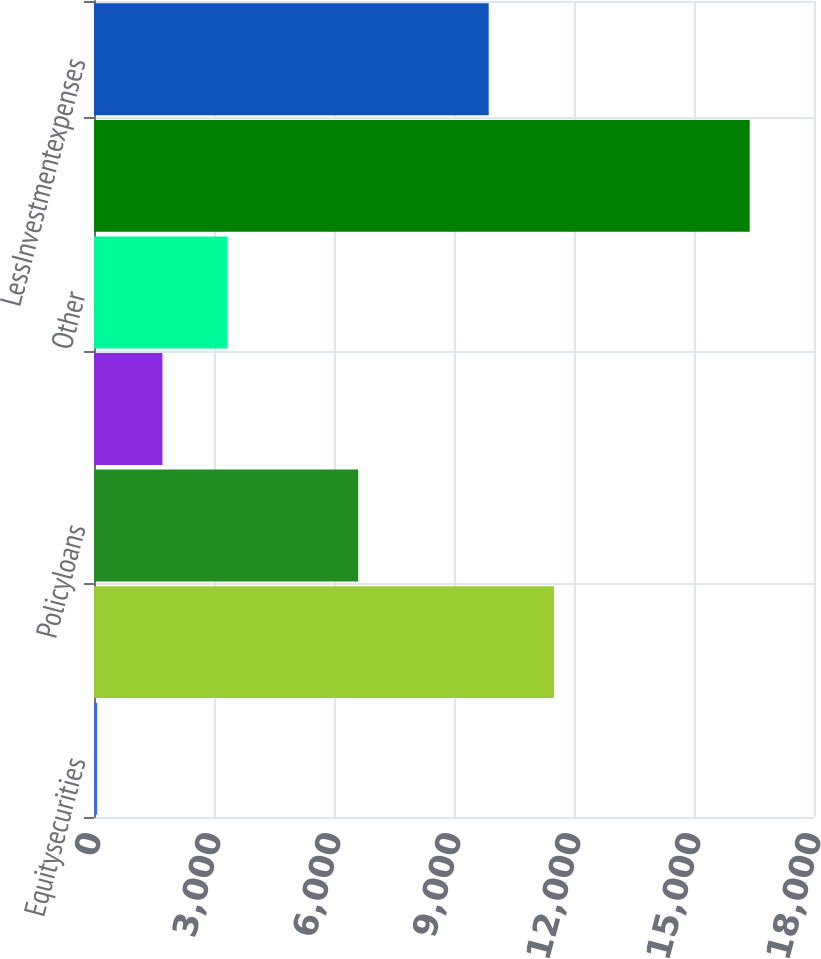<chart> <loc_0><loc_0><loc_500><loc_500><bar_chart><fcel>Equitysecurities<fcel>Mortgageandconsumerloans<fcel>Policyloans<fcel>Unnamed: 3<fcel>Other<fcel>Totalinvestmentincome<fcel>LessInvestmentexpenses<nl><fcel>79<fcel>11498.8<fcel>6604.6<fcel>1710.4<fcel>3341.8<fcel>16393<fcel>9867.4<nl></chart> 